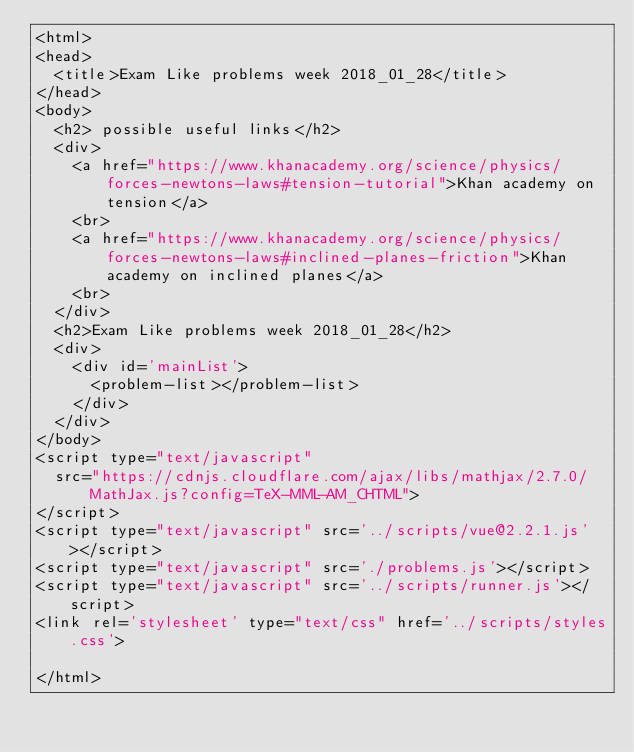<code> <loc_0><loc_0><loc_500><loc_500><_HTML_><html>
<head>
  <title>Exam Like problems week 2018_01_28</title>
</head>
<body>
  <h2> possible useful links</h2>
  <div>
    <a href="https://www.khanacademy.org/science/physics/forces-newtons-laws#tension-tutorial">Khan academy on tension</a>
    <br>
    <a href="https://www.khanacademy.org/science/physics/forces-newtons-laws#inclined-planes-friction">Khan academy on inclined planes</a>
    <br>
  </div>
  <h2>Exam Like problems week 2018_01_28</h2>
  <div>
    <div id='mainList'>
      <problem-list></problem-list>
    </div>
  </div>
</body>
<script type="text/javascript"
  src="https://cdnjs.cloudflare.com/ajax/libs/mathjax/2.7.0/MathJax.js?config=TeX-MML-AM_CHTML">
</script>
<script type="text/javascript" src='../scripts/vue@2.2.1.js'></script>
<script type="text/javascript" src='./problems.js'></script>
<script type="text/javascript" src='../scripts/runner.js'></script>
<link rel='stylesheet' type="text/css" href='../scripts/styles.css'>

</html>


</code> 